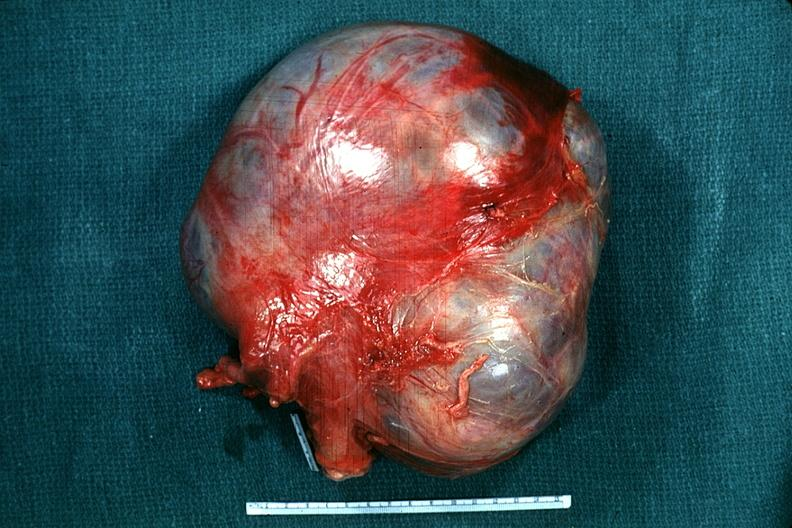where does this belong to?
Answer the question using a single word or phrase. Female reproductive system 